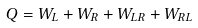<formula> <loc_0><loc_0><loc_500><loc_500>Q = W _ { L } + W _ { R } + W _ { L R } + W _ { R L }</formula> 